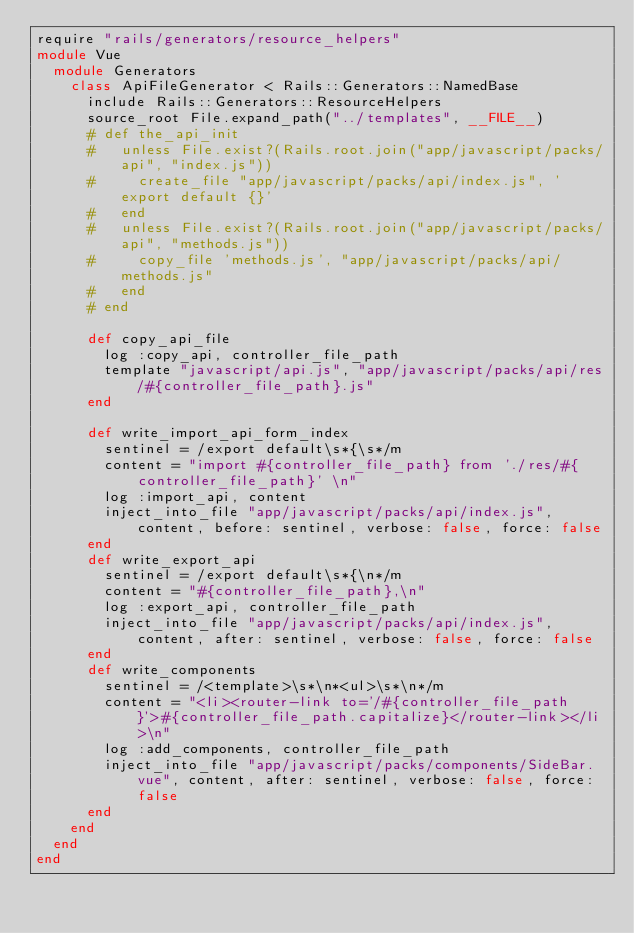<code> <loc_0><loc_0><loc_500><loc_500><_Ruby_>require "rails/generators/resource_helpers"
module Vue
  module Generators
    class ApiFileGenerator < Rails::Generators::NamedBase
      include Rails::Generators::ResourceHelpers
      source_root File.expand_path("../templates", __FILE__)
      # def the_api_init
      #   unless File.exist?(Rails.root.join("app/javascript/packs/api", "index.js"))
      #     create_file "app/javascript/packs/api/index.js", 'export default {}'
      #   end 
      #   unless File.exist?(Rails.root.join("app/javascript/packs/api", "methods.js"))
      #     copy_file 'methods.js', "app/javascript/packs/api/methods.js"
      #   end 
      # end

      def copy_api_file
        log :copy_api, controller_file_path
        template "javascript/api.js", "app/javascript/packs/api/res/#{controller_file_path}.js"
      end

      def write_import_api_form_index
        sentinel = /export default\s*{\s*/m
        content = "import #{controller_file_path} from './res/#{controller_file_path}' \n"
        log :import_api, content
        inject_into_file "app/javascript/packs/api/index.js", content, before: sentinel, verbose: false, force: false
      end
      def write_export_api
        sentinel = /export default\s*{\n*/m
        content = "#{controller_file_path},\n"
        log :export_api, controller_file_path
        inject_into_file "app/javascript/packs/api/index.js", content, after: sentinel, verbose: false, force: false
      end
      def write_components
        sentinel = /<template>\s*\n*<ul>\s*\n*/m
        content = "<li><router-link to='/#{controller_file_path}'>#{controller_file_path.capitalize}</router-link></li>\n"
        log :add_components, controller_file_path
        inject_into_file "app/javascript/packs/components/SideBar.vue", content, after: sentinel, verbose: false, force: false
      end
    end
  end
end</code> 